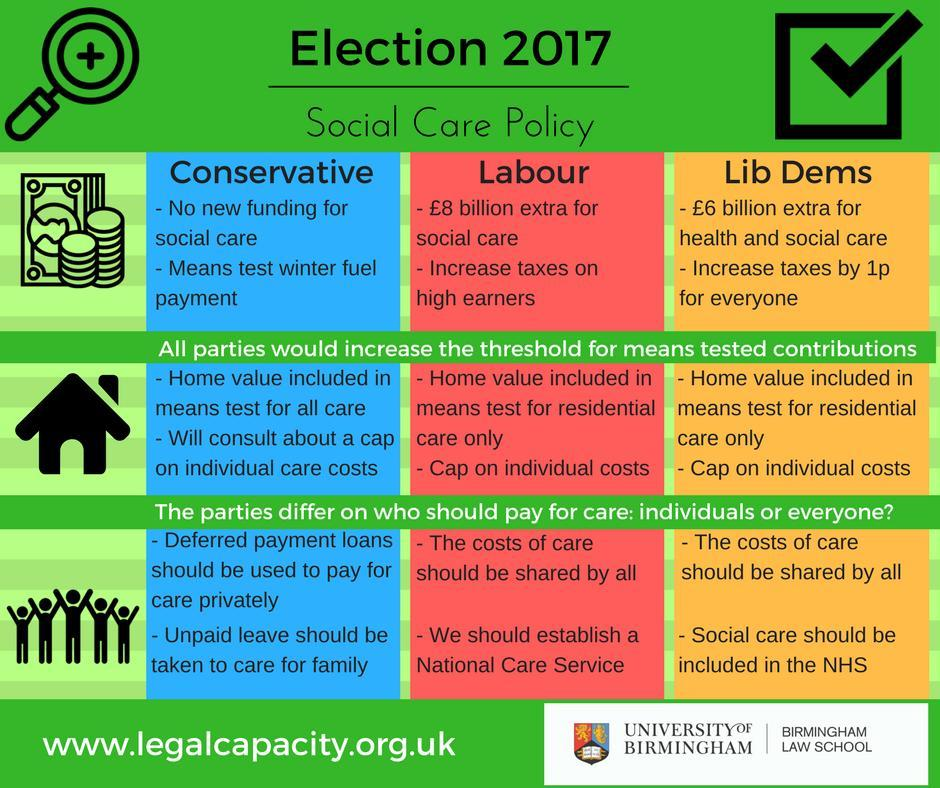Which party has the policy that social care should be included in the NHS?
Answer the question with a short phrase. Lib Dems Which party has no new funding for social care?? Conservative 